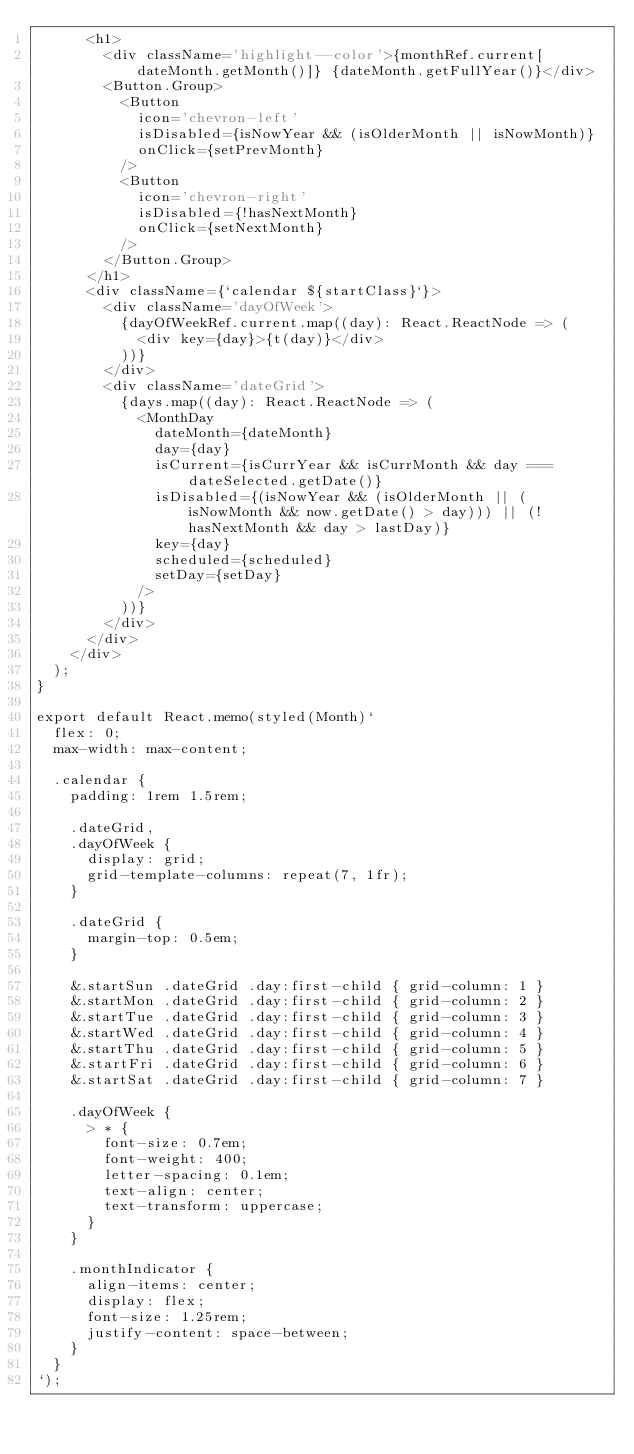Convert code to text. <code><loc_0><loc_0><loc_500><loc_500><_TypeScript_>      <h1>
        <div className='highlight--color'>{monthRef.current[dateMonth.getMonth()]} {dateMonth.getFullYear()}</div>
        <Button.Group>
          <Button
            icon='chevron-left'
            isDisabled={isNowYear && (isOlderMonth || isNowMonth)}
            onClick={setPrevMonth}
          />
          <Button
            icon='chevron-right'
            isDisabled={!hasNextMonth}
            onClick={setNextMonth}
          />
        </Button.Group>
      </h1>
      <div className={`calendar ${startClass}`}>
        <div className='dayOfWeek'>
          {dayOfWeekRef.current.map((day): React.ReactNode => (
            <div key={day}>{t(day)}</div>
          ))}
        </div>
        <div className='dateGrid'>
          {days.map((day): React.ReactNode => (
            <MonthDay
              dateMonth={dateMonth}
              day={day}
              isCurrent={isCurrYear && isCurrMonth && day === dateSelected.getDate()}
              isDisabled={(isNowYear && (isOlderMonth || (isNowMonth && now.getDate() > day))) || (!hasNextMonth && day > lastDay)}
              key={day}
              scheduled={scheduled}
              setDay={setDay}
            />
          ))}
        </div>
      </div>
    </div>
  );
}

export default React.memo(styled(Month)`
  flex: 0;
  max-width: max-content;

  .calendar {
    padding: 1rem 1.5rem;

    .dateGrid,
    .dayOfWeek {
      display: grid;
      grid-template-columns: repeat(7, 1fr);
    }

    .dateGrid {
      margin-top: 0.5em;
    }

    &.startSun .dateGrid .day:first-child { grid-column: 1 }
    &.startMon .dateGrid .day:first-child { grid-column: 2 }
    &.startTue .dateGrid .day:first-child { grid-column: 3 }
    &.startWed .dateGrid .day:first-child { grid-column: 4 }
    &.startThu .dateGrid .day:first-child { grid-column: 5 }
    &.startFri .dateGrid .day:first-child { grid-column: 6 }
    &.startSat .dateGrid .day:first-child { grid-column: 7 }

    .dayOfWeek {
      > * {
        font-size: 0.7em;
        font-weight: 400;
        letter-spacing: 0.1em;
        text-align: center;
        text-transform: uppercase;
      }
    }

    .monthIndicator {
      align-items: center;
      display: flex;
      font-size: 1.25rem;
      justify-content: space-between;
    }
  }
`);
</code> 